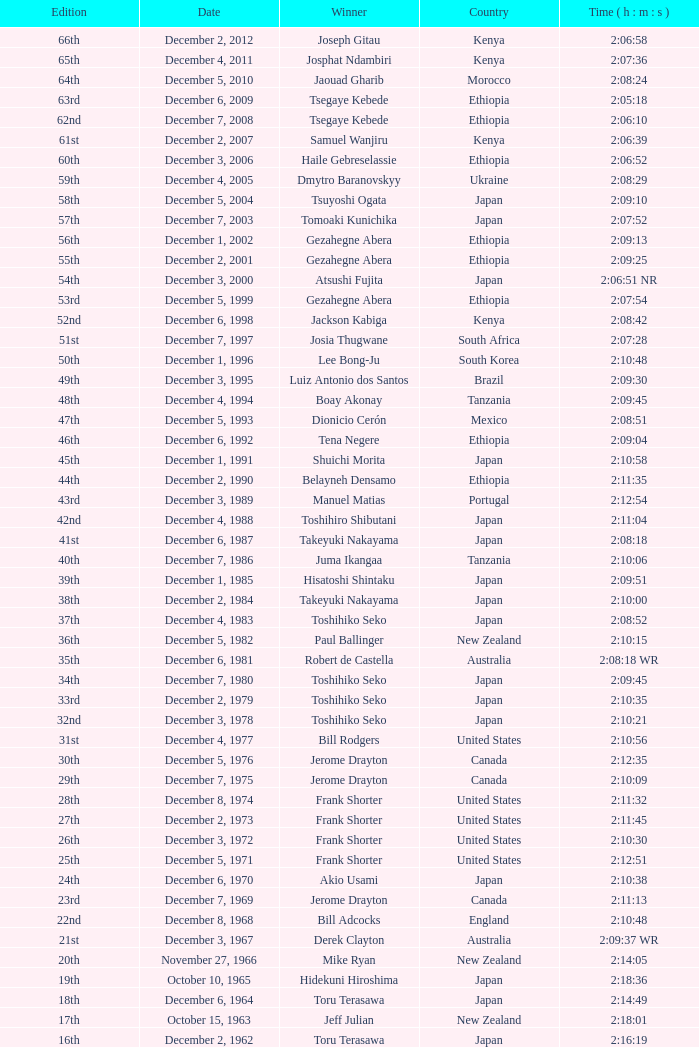What was the citizenship of the victor of the 42nd edition? Japan. 